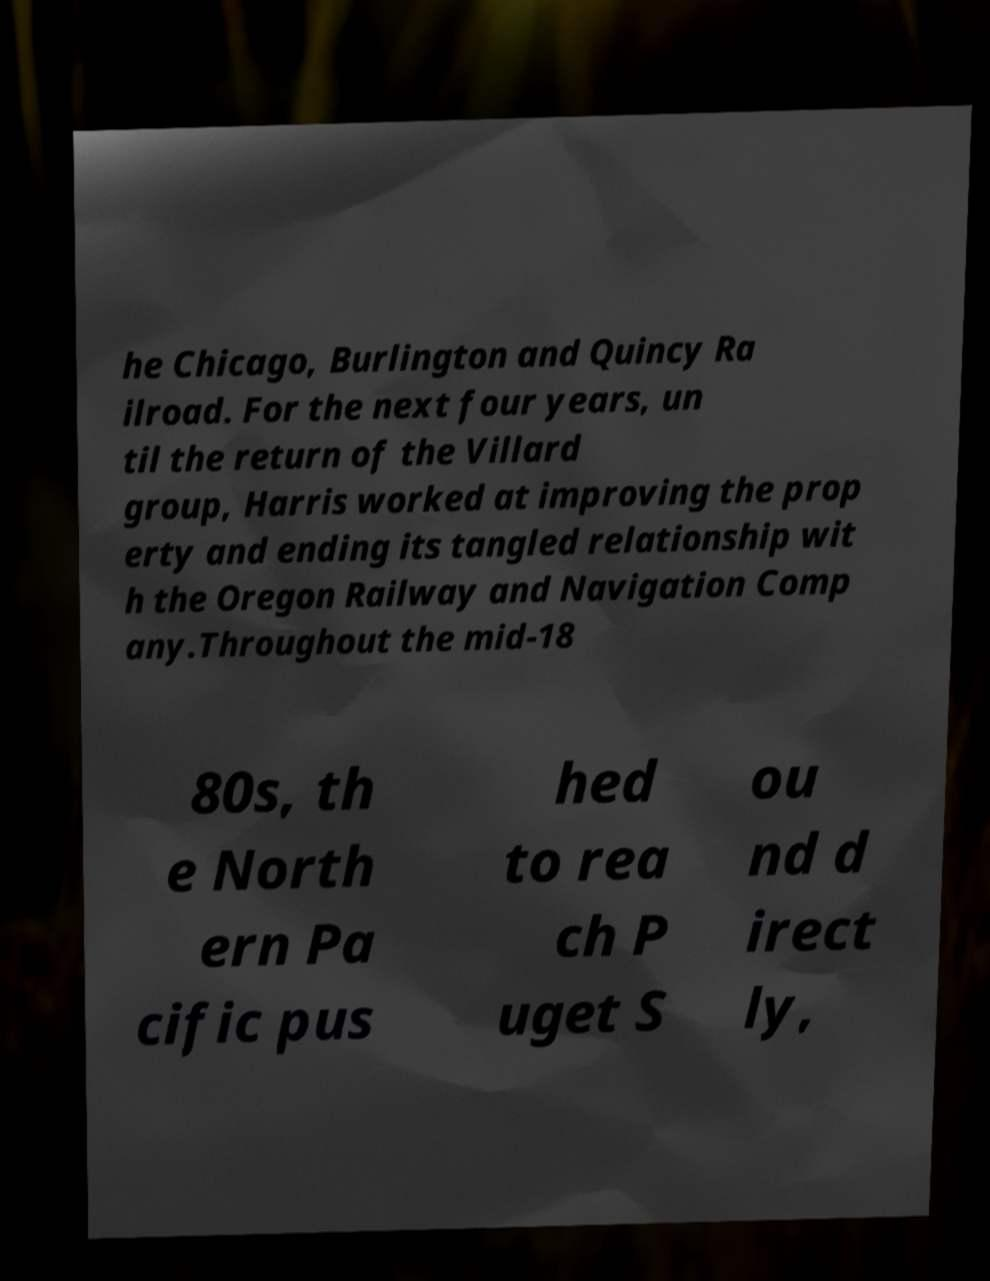Can you read and provide the text displayed in the image?This photo seems to have some interesting text. Can you extract and type it out for me? he Chicago, Burlington and Quincy Ra ilroad. For the next four years, un til the return of the Villard group, Harris worked at improving the prop erty and ending its tangled relationship wit h the Oregon Railway and Navigation Comp any.Throughout the mid-18 80s, th e North ern Pa cific pus hed to rea ch P uget S ou nd d irect ly, 